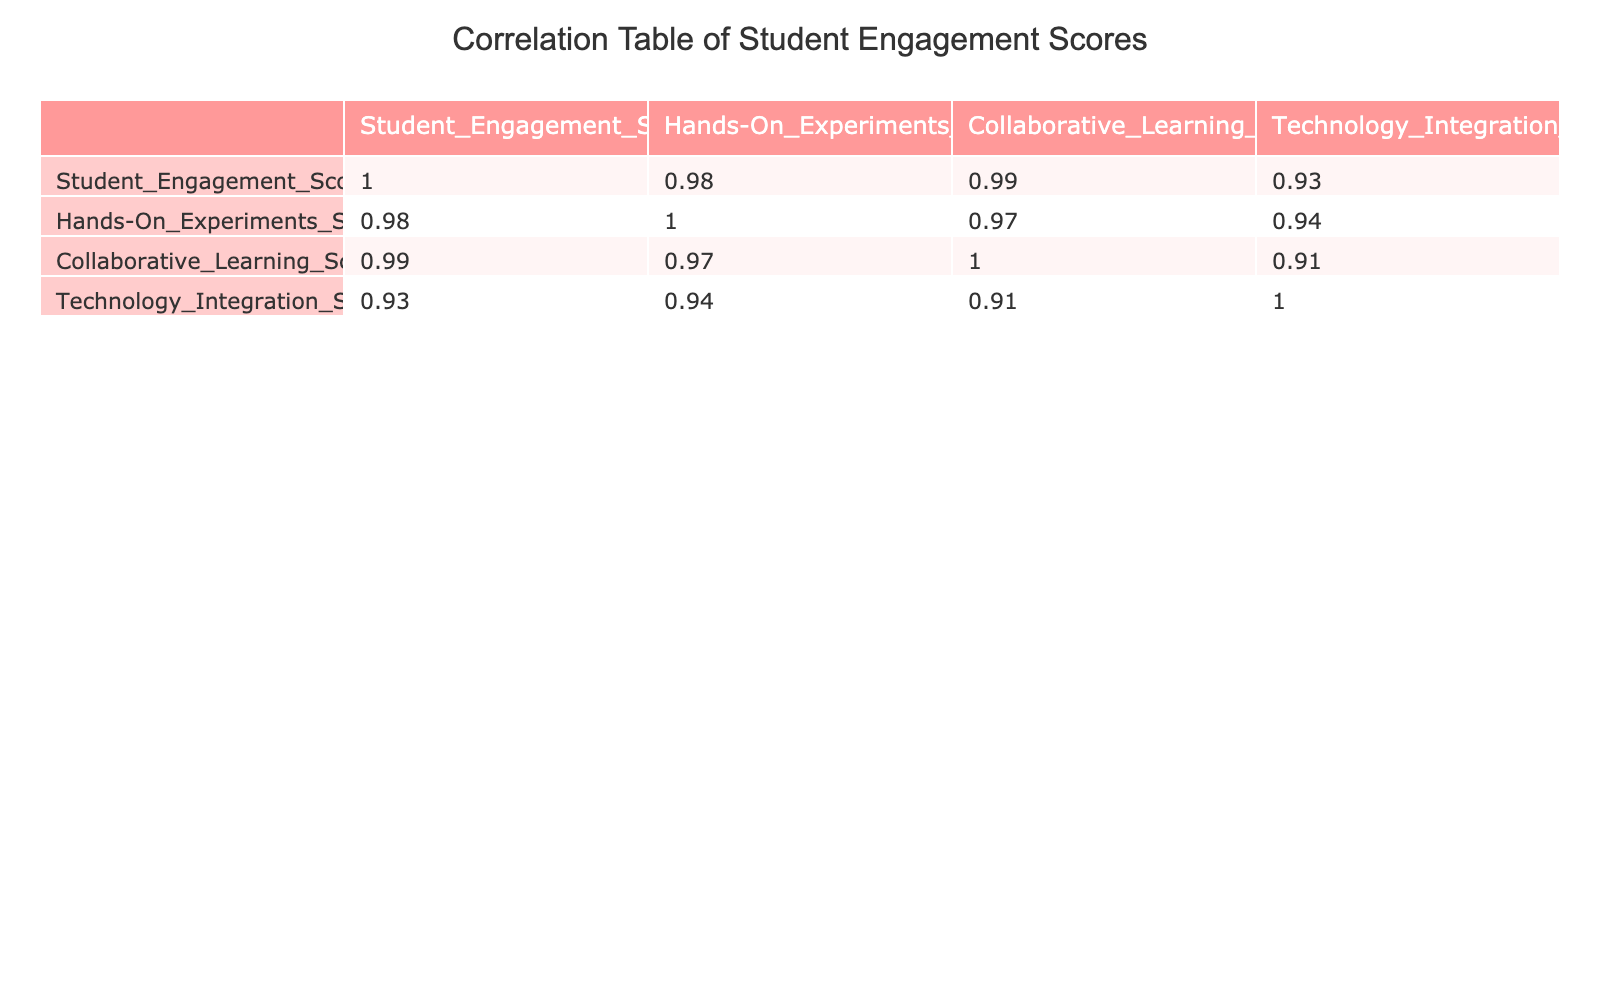What is the Student Engagement Score for Game-Based Learning? Referring to the "Student Engagement Score" column of the table, the value corresponding to "Game-Based Learning" is 90.
Answer: 90 Which teaching method has the highest Hands-On Experiments Score? Looking at the "Hands-On Experiments Score" column, the maximum value is 85, which corresponds to "Game-Based Learning."
Answer: Game-Based Learning Is the Inquiry-Based method positively correlated with the Student Engagement Score? By checking the correlation values, the correlation between "Inquiry-Based" and "Student Engagement Score" is 0.77, which indicates a positive correlation.
Answer: Yes What is the average Technology Integration Score for all teaching methods? To find the average, sum the Technology Integration Scores: (20 + 50 + 85 + 75 + 65 + 95 + 45 + 70) = 605. There are 8 teaching methods, so 605/8 = 75.625, which we can round to 76.
Answer: 76 Which teaching method has the lowest Student Engagement Score, and what is that score? The lowest score in the "Student Engagement Score" column is 25, which is associated with "Lecture-Based."
Answer: 25 What is the difference in the Collaborative Learning Scores between Project-Based and Flipped Classroom methods? The Collaborative Learning Score for "Project-Based" is 90, and for "Flipped Classroom" it is 75. The difference is 90 - 75 = 15.
Answer: 15 Is there any teaching method that has a Student Engagement Score above 80? By reviewing the "Student Engagement Score" column, three methods ("Project-Based," "Flipped Classroom," and "Game-Based Learning") have scores above 80.
Answer: Yes Which two teaching methods have the closest Student Engagement Scores, and what is the difference? The scores for "Mixed Methods" (65) and "Flipped Classroom" (80) are the closest. The difference between them is 80 - 65 = 15.
Answer: 15 What can be inferred about the correlation between hands-on experiments and student engagement? The table indicates that hands-on experiments correlate positively with student engagement, as the scores show that methods with higher hands-on components also receive higher engagement scores, like "Game-Based Learning" and "Project-Based."
Answer: Positive correlation 